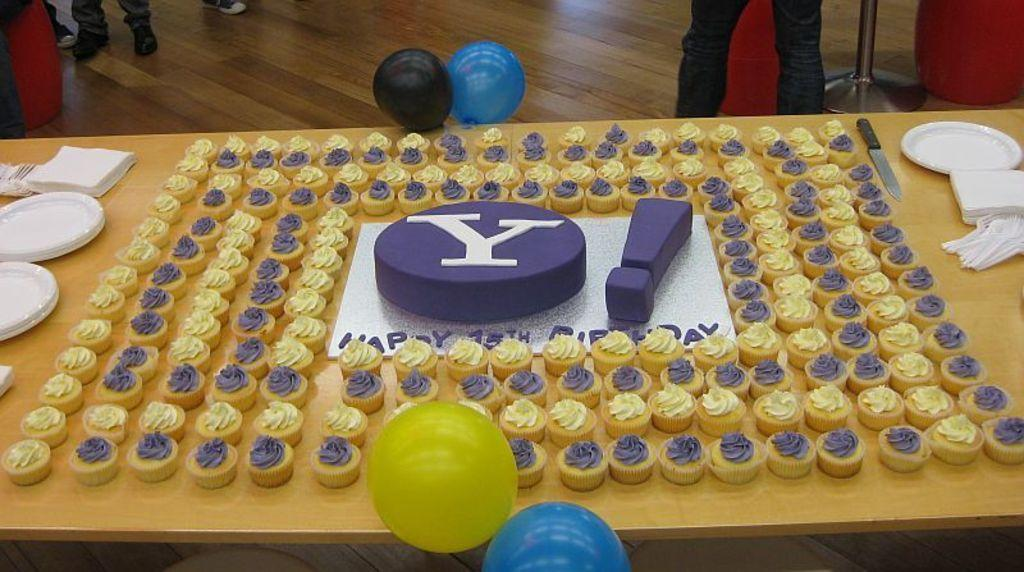What type of food is on the table in the image? There is a group of cakes on the table. What can be used to serve the cakes in the image? There are plates on the table. What might be used for cleaning or wiping in the image? Tissue papers are present on the table. What tool is visible on the table in the image? A knife is visible on the table. What decorative items are on the table in the image? Balloons are on the table. What is the position of the persons in the image? There are persons standing on the floor. What type of book is being read by the person in the image? There is no person reading a book in the image; the focus is on the cakes and other items on the table. 